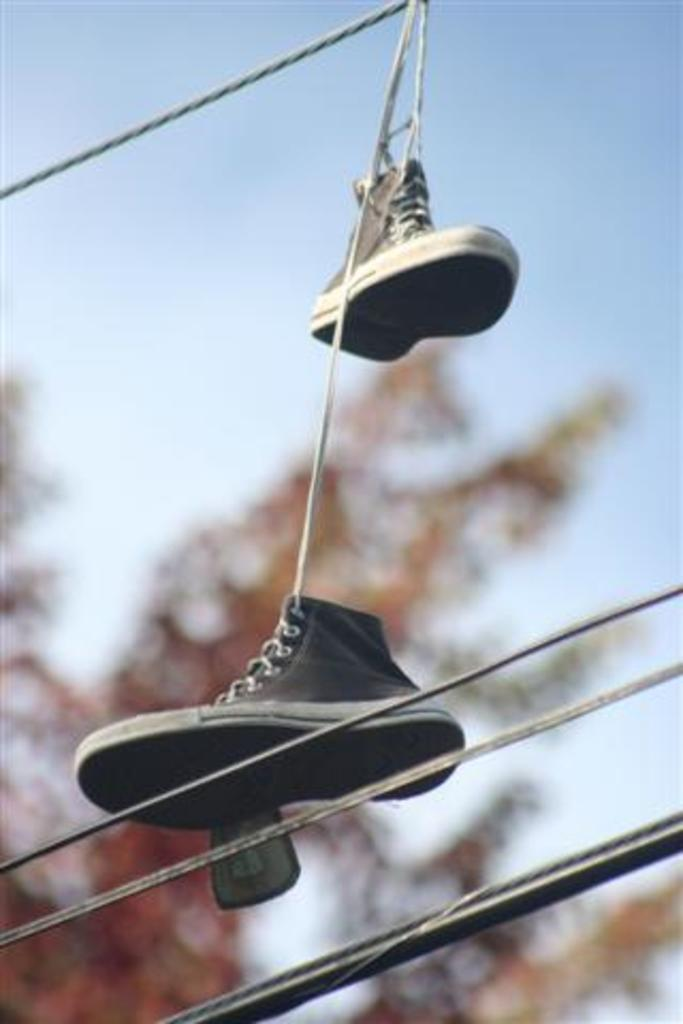What objects are hanging in the image? There are two shoes hanging in the image. How might the shoes be suspended in the air? The shoes may be hanging on ropes, as suggested by the facts. What else can be seen at the bottom of the image? There are shoes at the bottom of the image. What is visible at the top of the image? The sky is visible at the top of the image. Can you identify any natural elements in the image? There may be a tree visible in the image. What type of sign can be seen hanging from the shoes in the image? There is no sign present in the image; it features two shoes hanging on ropes. Are the shoes made of metal in the image? The facts do not specify the material of the shoes, so we cannot determine if they are made of metal. 